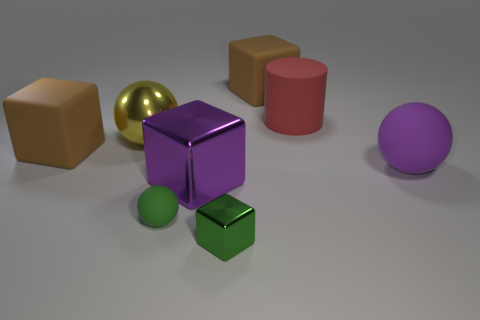Subtract all big cubes. How many cubes are left? 1 Subtract all purple balls. How many balls are left? 2 Subtract all cylinders. How many objects are left? 7 Add 2 brown blocks. How many objects exist? 10 Subtract 2 cubes. How many cubes are left? 2 Subtract all brown cylinders. Subtract all purple balls. How many cylinders are left? 1 Subtract all purple cylinders. How many red blocks are left? 0 Subtract all small blue metallic cylinders. Subtract all brown rubber blocks. How many objects are left? 6 Add 4 brown matte blocks. How many brown matte blocks are left? 6 Add 6 cylinders. How many cylinders exist? 7 